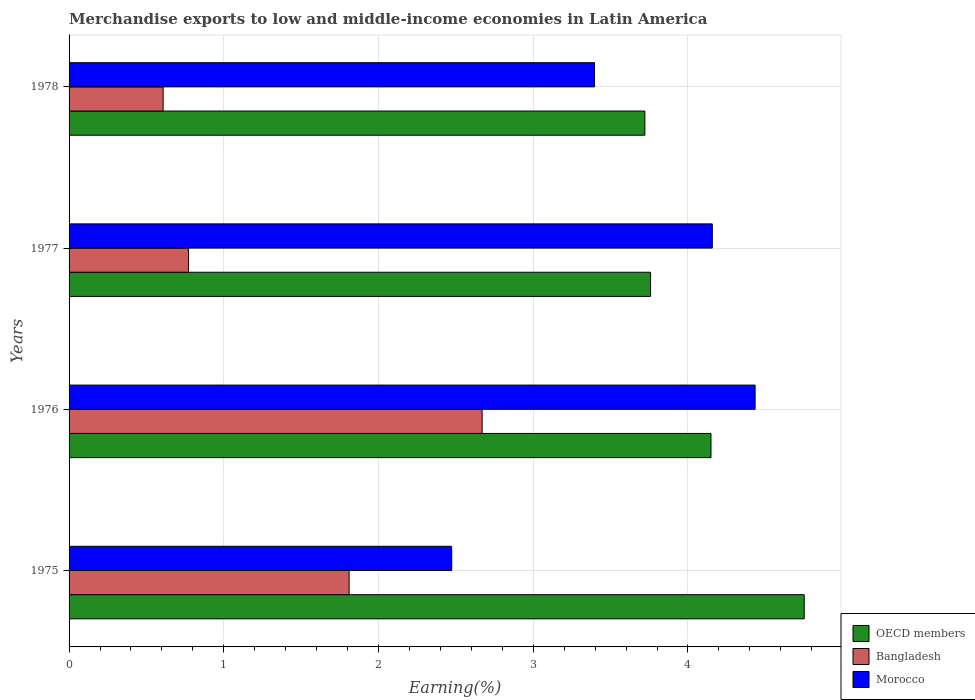How many different coloured bars are there?
Provide a succinct answer. 3. Are the number of bars on each tick of the Y-axis equal?
Your response must be concise. Yes. How many bars are there on the 2nd tick from the bottom?
Ensure brevity in your answer.  3. What is the label of the 1st group of bars from the top?
Your answer should be compact. 1978. What is the percentage of amount earned from merchandise exports in OECD members in 1975?
Provide a succinct answer. 4.75. Across all years, what is the maximum percentage of amount earned from merchandise exports in OECD members?
Offer a very short reply. 4.75. Across all years, what is the minimum percentage of amount earned from merchandise exports in Morocco?
Provide a succinct answer. 2.47. In which year was the percentage of amount earned from merchandise exports in Bangladesh maximum?
Offer a terse response. 1976. In which year was the percentage of amount earned from merchandise exports in OECD members minimum?
Give a very brief answer. 1978. What is the total percentage of amount earned from merchandise exports in Bangladesh in the graph?
Keep it short and to the point. 5.86. What is the difference between the percentage of amount earned from merchandise exports in OECD members in 1975 and that in 1977?
Ensure brevity in your answer.  0.99. What is the difference between the percentage of amount earned from merchandise exports in Bangladesh in 1978 and the percentage of amount earned from merchandise exports in Morocco in 1976?
Offer a terse response. -3.83. What is the average percentage of amount earned from merchandise exports in Morocco per year?
Your response must be concise. 3.62. In the year 1978, what is the difference between the percentage of amount earned from merchandise exports in OECD members and percentage of amount earned from merchandise exports in Bangladesh?
Provide a succinct answer. 3.11. What is the ratio of the percentage of amount earned from merchandise exports in Bangladesh in 1976 to that in 1978?
Offer a very short reply. 4.39. What is the difference between the highest and the second highest percentage of amount earned from merchandise exports in Bangladesh?
Make the answer very short. 0.86. What is the difference between the highest and the lowest percentage of amount earned from merchandise exports in OECD members?
Keep it short and to the point. 1.03. In how many years, is the percentage of amount earned from merchandise exports in OECD members greater than the average percentage of amount earned from merchandise exports in OECD members taken over all years?
Give a very brief answer. 2. Is the sum of the percentage of amount earned from merchandise exports in Morocco in 1976 and 1977 greater than the maximum percentage of amount earned from merchandise exports in Bangladesh across all years?
Offer a very short reply. Yes. What does the 2nd bar from the bottom in 1978 represents?
Provide a short and direct response. Bangladesh. How many bars are there?
Keep it short and to the point. 12. Are all the bars in the graph horizontal?
Your response must be concise. Yes. What is the difference between two consecutive major ticks on the X-axis?
Make the answer very short. 1. Are the values on the major ticks of X-axis written in scientific E-notation?
Provide a succinct answer. No. Does the graph contain grids?
Give a very brief answer. Yes. What is the title of the graph?
Offer a terse response. Merchandise exports to low and middle-income economies in Latin America. What is the label or title of the X-axis?
Your answer should be very brief. Earning(%). What is the label or title of the Y-axis?
Your answer should be compact. Years. What is the Earning(%) in OECD members in 1975?
Keep it short and to the point. 4.75. What is the Earning(%) in Bangladesh in 1975?
Your answer should be very brief. 1.81. What is the Earning(%) in Morocco in 1975?
Your response must be concise. 2.47. What is the Earning(%) of OECD members in 1976?
Provide a short and direct response. 4.15. What is the Earning(%) of Bangladesh in 1976?
Make the answer very short. 2.67. What is the Earning(%) of Morocco in 1976?
Provide a succinct answer. 4.43. What is the Earning(%) of OECD members in 1977?
Provide a succinct answer. 3.76. What is the Earning(%) of Bangladesh in 1977?
Provide a short and direct response. 0.77. What is the Earning(%) of Morocco in 1977?
Your response must be concise. 4.16. What is the Earning(%) in OECD members in 1978?
Your answer should be compact. 3.72. What is the Earning(%) of Bangladesh in 1978?
Make the answer very short. 0.61. What is the Earning(%) in Morocco in 1978?
Ensure brevity in your answer.  3.4. Across all years, what is the maximum Earning(%) in OECD members?
Your answer should be very brief. 4.75. Across all years, what is the maximum Earning(%) in Bangladesh?
Offer a terse response. 2.67. Across all years, what is the maximum Earning(%) of Morocco?
Give a very brief answer. 4.43. Across all years, what is the minimum Earning(%) in OECD members?
Offer a terse response. 3.72. Across all years, what is the minimum Earning(%) of Bangladesh?
Offer a terse response. 0.61. Across all years, what is the minimum Earning(%) of Morocco?
Ensure brevity in your answer.  2.47. What is the total Earning(%) in OECD members in the graph?
Keep it short and to the point. 16.38. What is the total Earning(%) in Bangladesh in the graph?
Offer a very short reply. 5.86. What is the total Earning(%) of Morocco in the graph?
Your answer should be very brief. 14.46. What is the difference between the Earning(%) of OECD members in 1975 and that in 1976?
Make the answer very short. 0.6. What is the difference between the Earning(%) in Bangladesh in 1975 and that in 1976?
Provide a short and direct response. -0.86. What is the difference between the Earning(%) in Morocco in 1975 and that in 1976?
Make the answer very short. -1.96. What is the difference between the Earning(%) of Bangladesh in 1975 and that in 1977?
Provide a short and direct response. 1.04. What is the difference between the Earning(%) of Morocco in 1975 and that in 1977?
Ensure brevity in your answer.  -1.68. What is the difference between the Earning(%) in OECD members in 1975 and that in 1978?
Make the answer very short. 1.03. What is the difference between the Earning(%) in Bangladesh in 1975 and that in 1978?
Offer a terse response. 1.2. What is the difference between the Earning(%) in Morocco in 1975 and that in 1978?
Give a very brief answer. -0.92. What is the difference between the Earning(%) of OECD members in 1976 and that in 1977?
Make the answer very short. 0.39. What is the difference between the Earning(%) of Bangladesh in 1976 and that in 1977?
Offer a terse response. 1.9. What is the difference between the Earning(%) in Morocco in 1976 and that in 1977?
Offer a very short reply. 0.28. What is the difference between the Earning(%) in OECD members in 1976 and that in 1978?
Keep it short and to the point. 0.43. What is the difference between the Earning(%) in Bangladesh in 1976 and that in 1978?
Provide a succinct answer. 2.06. What is the difference between the Earning(%) of Morocco in 1976 and that in 1978?
Your answer should be very brief. 1.04. What is the difference between the Earning(%) in OECD members in 1977 and that in 1978?
Provide a succinct answer. 0.04. What is the difference between the Earning(%) of Bangladesh in 1977 and that in 1978?
Provide a short and direct response. 0.16. What is the difference between the Earning(%) in Morocco in 1977 and that in 1978?
Keep it short and to the point. 0.76. What is the difference between the Earning(%) in OECD members in 1975 and the Earning(%) in Bangladesh in 1976?
Make the answer very short. 2.08. What is the difference between the Earning(%) of OECD members in 1975 and the Earning(%) of Morocco in 1976?
Your response must be concise. 0.32. What is the difference between the Earning(%) of Bangladesh in 1975 and the Earning(%) of Morocco in 1976?
Keep it short and to the point. -2.62. What is the difference between the Earning(%) in OECD members in 1975 and the Earning(%) in Bangladesh in 1977?
Make the answer very short. 3.98. What is the difference between the Earning(%) in OECD members in 1975 and the Earning(%) in Morocco in 1977?
Offer a very short reply. 0.59. What is the difference between the Earning(%) in Bangladesh in 1975 and the Earning(%) in Morocco in 1977?
Make the answer very short. -2.35. What is the difference between the Earning(%) in OECD members in 1975 and the Earning(%) in Bangladesh in 1978?
Your response must be concise. 4.14. What is the difference between the Earning(%) in OECD members in 1975 and the Earning(%) in Morocco in 1978?
Provide a succinct answer. 1.36. What is the difference between the Earning(%) of Bangladesh in 1975 and the Earning(%) of Morocco in 1978?
Ensure brevity in your answer.  -1.59. What is the difference between the Earning(%) in OECD members in 1976 and the Earning(%) in Bangladesh in 1977?
Offer a very short reply. 3.38. What is the difference between the Earning(%) of OECD members in 1976 and the Earning(%) of Morocco in 1977?
Give a very brief answer. -0.01. What is the difference between the Earning(%) of Bangladesh in 1976 and the Earning(%) of Morocco in 1977?
Your answer should be compact. -1.49. What is the difference between the Earning(%) of OECD members in 1976 and the Earning(%) of Bangladesh in 1978?
Your answer should be very brief. 3.54. What is the difference between the Earning(%) in OECD members in 1976 and the Earning(%) in Morocco in 1978?
Your answer should be compact. 0.75. What is the difference between the Earning(%) of Bangladesh in 1976 and the Earning(%) of Morocco in 1978?
Ensure brevity in your answer.  -0.73. What is the difference between the Earning(%) in OECD members in 1977 and the Earning(%) in Bangladesh in 1978?
Provide a succinct answer. 3.15. What is the difference between the Earning(%) in OECD members in 1977 and the Earning(%) in Morocco in 1978?
Ensure brevity in your answer.  0.36. What is the difference between the Earning(%) in Bangladesh in 1977 and the Earning(%) in Morocco in 1978?
Your response must be concise. -2.62. What is the average Earning(%) of OECD members per year?
Your answer should be very brief. 4.09. What is the average Earning(%) in Bangladesh per year?
Offer a terse response. 1.46. What is the average Earning(%) of Morocco per year?
Provide a short and direct response. 3.62. In the year 1975, what is the difference between the Earning(%) in OECD members and Earning(%) in Bangladesh?
Your answer should be very brief. 2.94. In the year 1975, what is the difference between the Earning(%) of OECD members and Earning(%) of Morocco?
Provide a succinct answer. 2.28. In the year 1975, what is the difference between the Earning(%) in Bangladesh and Earning(%) in Morocco?
Your response must be concise. -0.66. In the year 1976, what is the difference between the Earning(%) of OECD members and Earning(%) of Bangladesh?
Provide a succinct answer. 1.48. In the year 1976, what is the difference between the Earning(%) of OECD members and Earning(%) of Morocco?
Your response must be concise. -0.29. In the year 1976, what is the difference between the Earning(%) in Bangladesh and Earning(%) in Morocco?
Keep it short and to the point. -1.76. In the year 1977, what is the difference between the Earning(%) of OECD members and Earning(%) of Bangladesh?
Provide a succinct answer. 2.99. In the year 1977, what is the difference between the Earning(%) of OECD members and Earning(%) of Morocco?
Offer a terse response. -0.4. In the year 1977, what is the difference between the Earning(%) in Bangladesh and Earning(%) in Morocco?
Your answer should be compact. -3.39. In the year 1978, what is the difference between the Earning(%) in OECD members and Earning(%) in Bangladesh?
Keep it short and to the point. 3.11. In the year 1978, what is the difference between the Earning(%) in OECD members and Earning(%) in Morocco?
Offer a very short reply. 0.33. In the year 1978, what is the difference between the Earning(%) in Bangladesh and Earning(%) in Morocco?
Your response must be concise. -2.79. What is the ratio of the Earning(%) in OECD members in 1975 to that in 1976?
Ensure brevity in your answer.  1.15. What is the ratio of the Earning(%) of Bangladesh in 1975 to that in 1976?
Give a very brief answer. 0.68. What is the ratio of the Earning(%) of Morocco in 1975 to that in 1976?
Provide a succinct answer. 0.56. What is the ratio of the Earning(%) in OECD members in 1975 to that in 1977?
Make the answer very short. 1.26. What is the ratio of the Earning(%) of Bangladesh in 1975 to that in 1977?
Your response must be concise. 2.34. What is the ratio of the Earning(%) in Morocco in 1975 to that in 1977?
Ensure brevity in your answer.  0.59. What is the ratio of the Earning(%) in OECD members in 1975 to that in 1978?
Your answer should be compact. 1.28. What is the ratio of the Earning(%) of Bangladesh in 1975 to that in 1978?
Provide a short and direct response. 2.98. What is the ratio of the Earning(%) of Morocco in 1975 to that in 1978?
Your answer should be compact. 0.73. What is the ratio of the Earning(%) of OECD members in 1976 to that in 1977?
Your answer should be compact. 1.1. What is the ratio of the Earning(%) of Bangladesh in 1976 to that in 1977?
Give a very brief answer. 3.46. What is the ratio of the Earning(%) in Morocco in 1976 to that in 1977?
Offer a very short reply. 1.07. What is the ratio of the Earning(%) in OECD members in 1976 to that in 1978?
Make the answer very short. 1.11. What is the ratio of the Earning(%) in Bangladesh in 1976 to that in 1978?
Offer a terse response. 4.39. What is the ratio of the Earning(%) in Morocco in 1976 to that in 1978?
Give a very brief answer. 1.31. What is the ratio of the Earning(%) in OECD members in 1977 to that in 1978?
Keep it short and to the point. 1.01. What is the ratio of the Earning(%) in Bangladesh in 1977 to that in 1978?
Provide a succinct answer. 1.27. What is the ratio of the Earning(%) of Morocco in 1977 to that in 1978?
Your answer should be compact. 1.22. What is the difference between the highest and the second highest Earning(%) of OECD members?
Ensure brevity in your answer.  0.6. What is the difference between the highest and the second highest Earning(%) of Bangladesh?
Offer a terse response. 0.86. What is the difference between the highest and the second highest Earning(%) of Morocco?
Your response must be concise. 0.28. What is the difference between the highest and the lowest Earning(%) of OECD members?
Ensure brevity in your answer.  1.03. What is the difference between the highest and the lowest Earning(%) in Bangladesh?
Make the answer very short. 2.06. What is the difference between the highest and the lowest Earning(%) in Morocco?
Your answer should be compact. 1.96. 